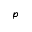Convert formula to latex. <formula><loc_0><loc_0><loc_500><loc_500>p</formula> 